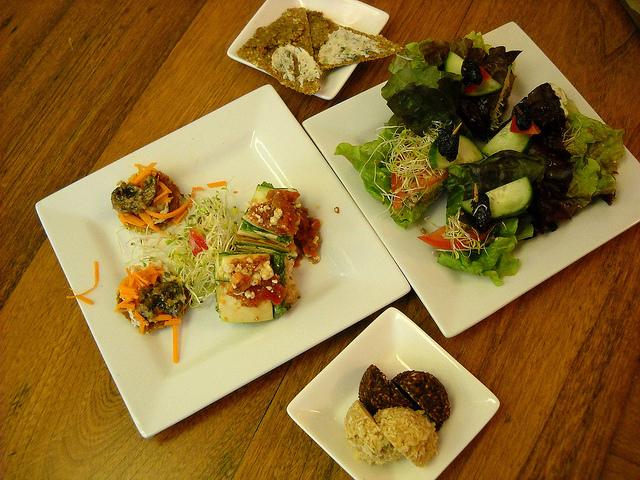Do each plates have carrots on them?
Answer briefly. No. How many plates of food?
Be succinct. 4. What are the green vegetables on the plate?
Be succinct. Lettuce. What color are the plates?
Short answer required. White. 